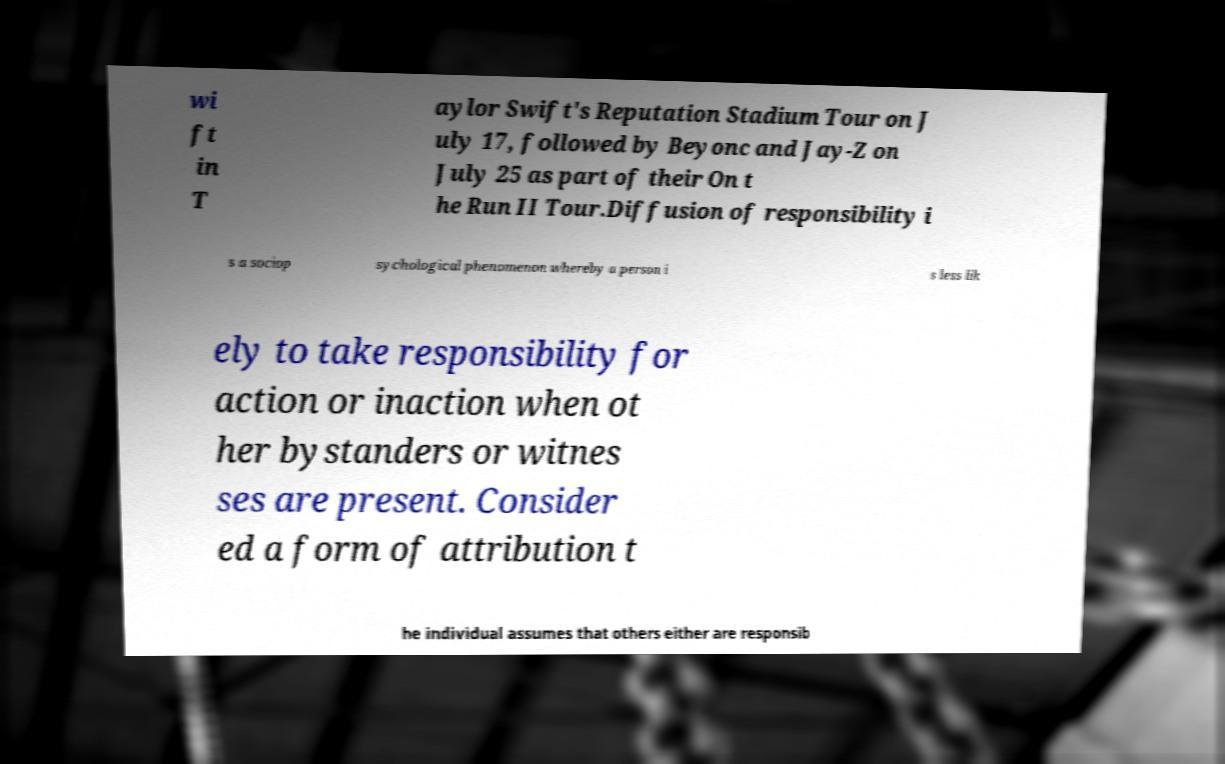Could you extract and type out the text from this image? wi ft in T aylor Swift's Reputation Stadium Tour on J uly 17, followed by Beyonc and Jay-Z on July 25 as part of their On t he Run II Tour.Diffusion of responsibility i s a sociop sychological phenomenon whereby a person i s less lik ely to take responsibility for action or inaction when ot her bystanders or witnes ses are present. Consider ed a form of attribution t he individual assumes that others either are responsib 